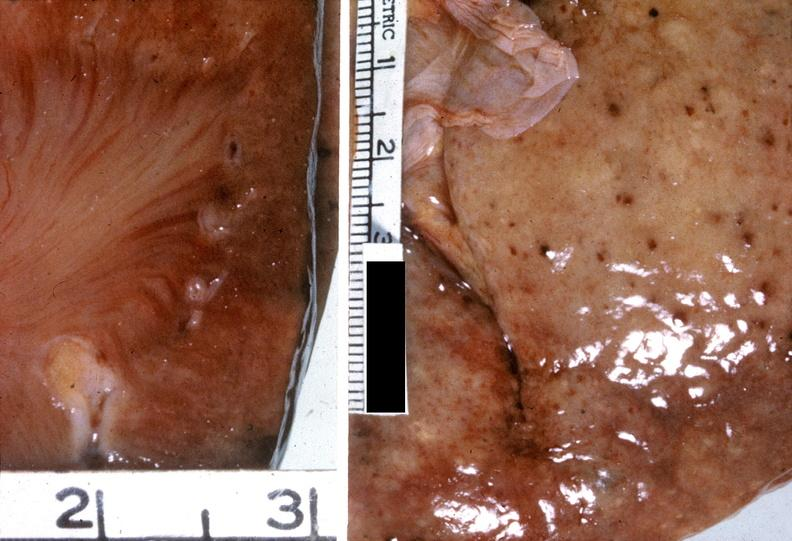what does this image show?
Answer the question using a single word or phrase. Kidney 